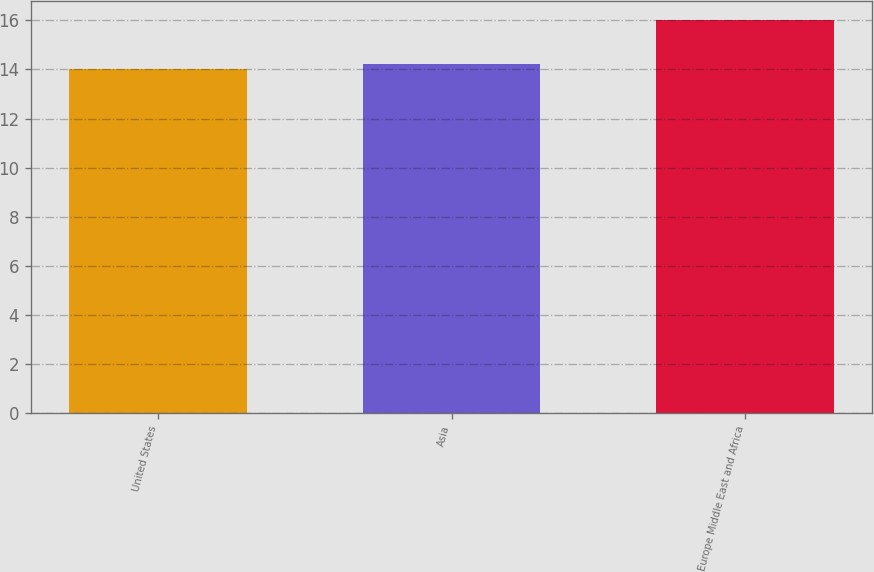<chart> <loc_0><loc_0><loc_500><loc_500><bar_chart><fcel>United States<fcel>Asia<fcel>Europe Middle East and Africa<nl><fcel>14<fcel>14.2<fcel>16<nl></chart> 